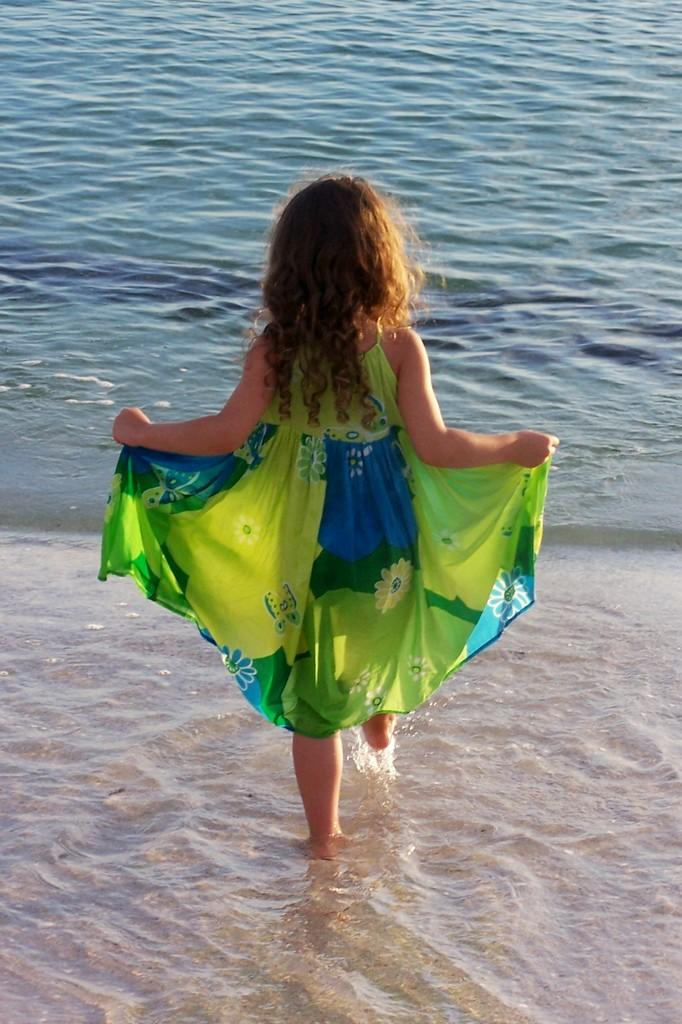What is the main subject of the image? The main subject of the image is a small girl. How is the girl positioned in the image? The girl is seen from the back side. What is the girl wearing in the image? The girl is wearing a blue and green dress. What is the girl doing in the image? The girl is walking in the sea water. What can be seen in the background of the image? There is blue water visible in the background. What type of instrument is the girl playing in the image? There is no instrument present in the image; the girl is walking in the sea water. Can you tell me how many cherries are on the girl's dress in the image? There are no cherries visible on the girl's dress in the image; she is wearing a blue and green dress. 